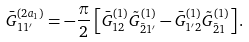Convert formula to latex. <formula><loc_0><loc_0><loc_500><loc_500>\bar { G } _ { 1 1 ^ { \prime } } ^ { ( 2 a _ { 1 } ) } = - \frac { \pi } { 2 } \left [ \bar { G } _ { 1 2 } ^ { ( 1 ) } \tilde { G } _ { \bar { 2 } 1 ^ { \prime } } ^ { ( 1 ) } - \bar { G } _ { 1 ^ { \prime } 2 } ^ { ( 1 ) } \tilde { G } _ { \bar { 2 } 1 } ^ { ( 1 ) } \right ] .</formula> 